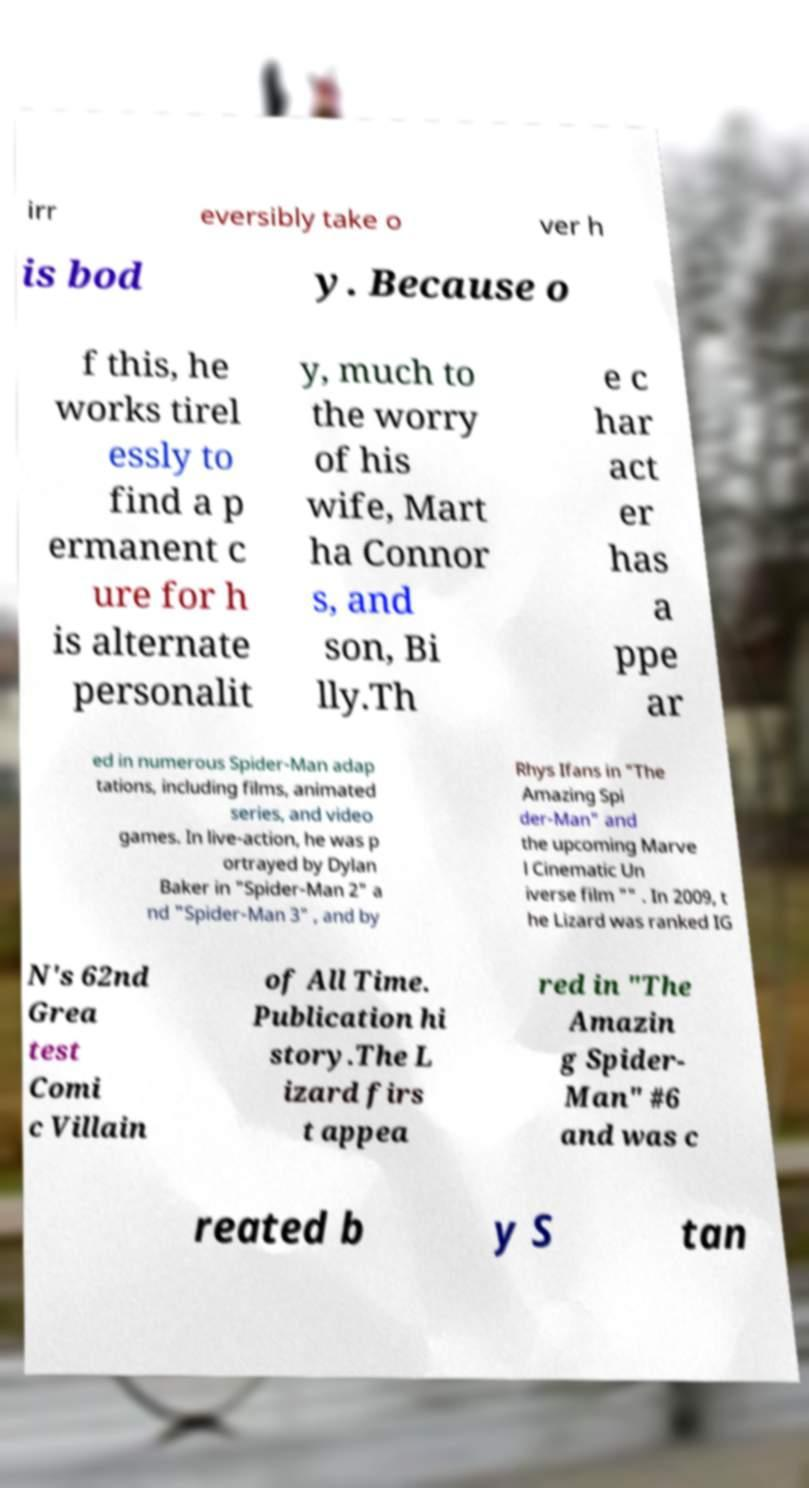I need the written content from this picture converted into text. Can you do that? irr eversibly take o ver h is bod y. Because o f this, he works tirel essly to find a p ermanent c ure for h is alternate personalit y, much to the worry of his wife, Mart ha Connor s, and son, Bi lly.Th e c har act er has a ppe ar ed in numerous Spider-Man adap tations, including films, animated series, and video games. In live-action, he was p ortrayed by Dylan Baker in "Spider-Man 2" a nd "Spider-Man 3" , and by Rhys Ifans in "The Amazing Spi der-Man" and the upcoming Marve l Cinematic Un iverse film "" . In 2009, t he Lizard was ranked IG N's 62nd Grea test Comi c Villain of All Time. Publication hi story.The L izard firs t appea red in "The Amazin g Spider- Man" #6 and was c reated b y S tan 